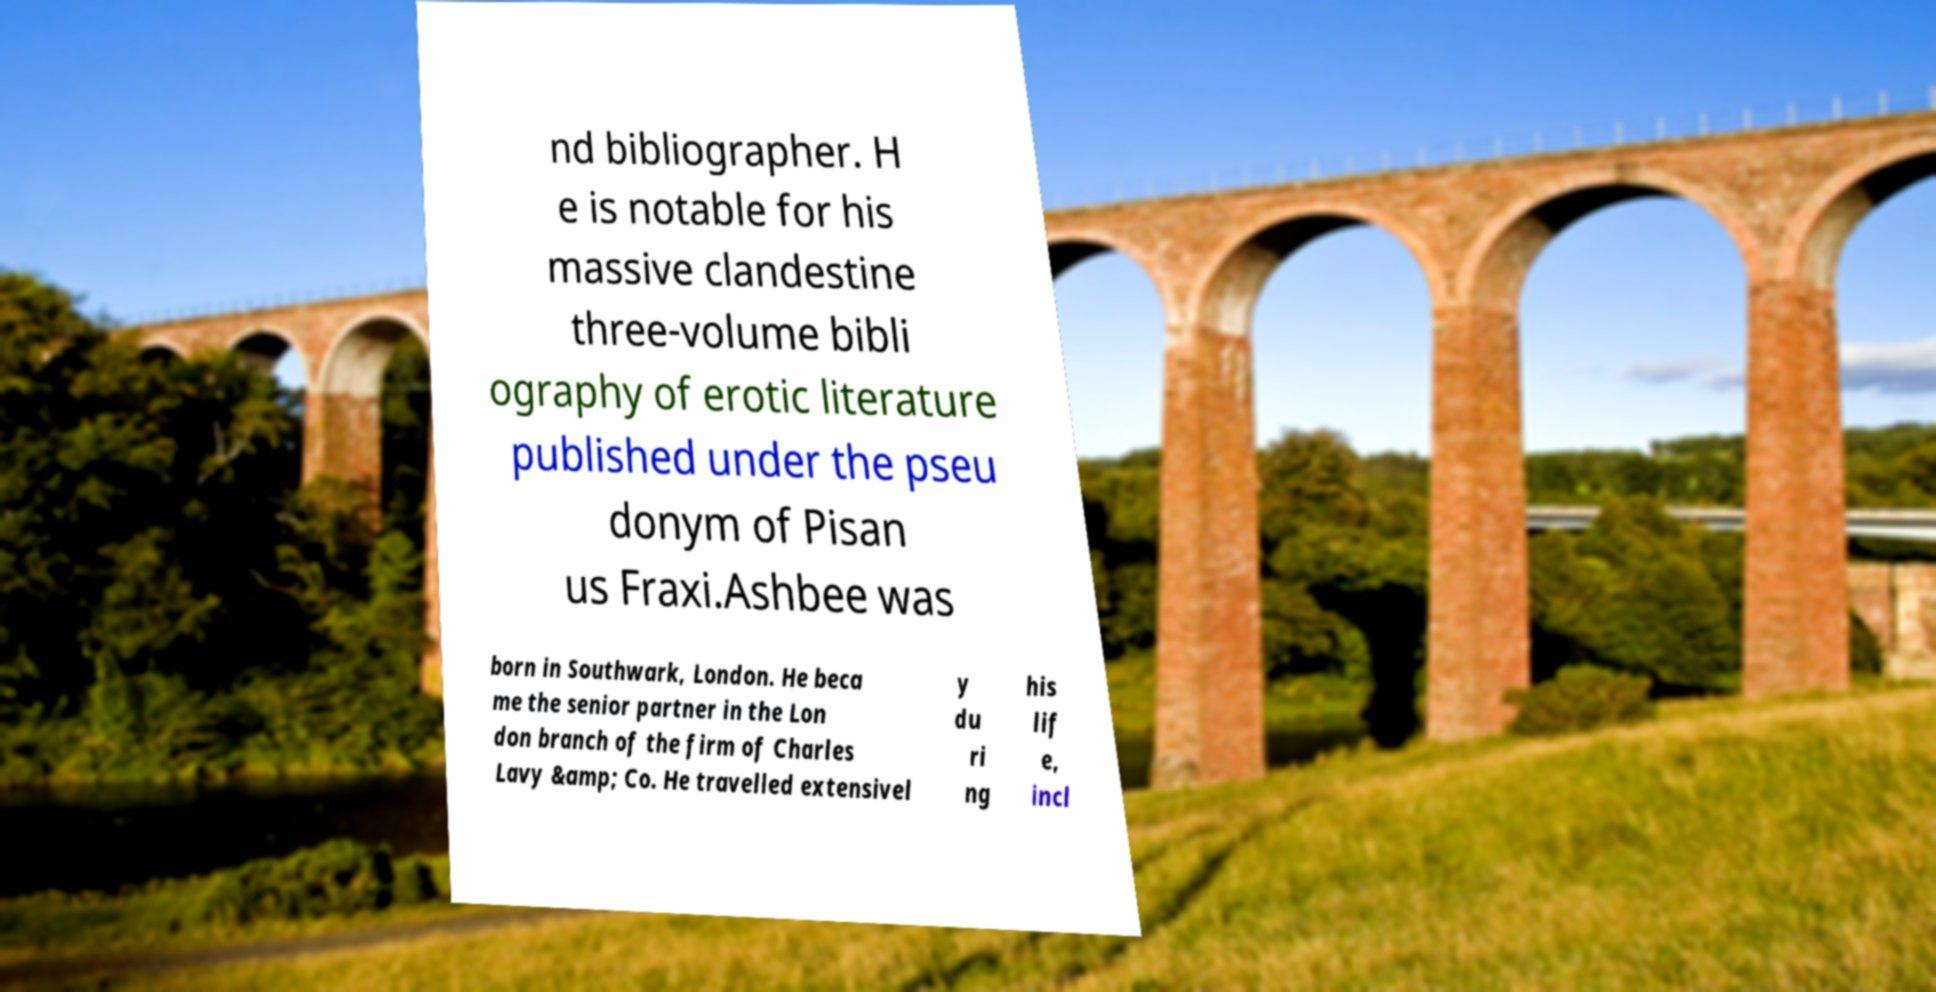Can you accurately transcribe the text from the provided image for me? nd bibliographer. H e is notable for his massive clandestine three-volume bibli ography of erotic literature published under the pseu donym of Pisan us Fraxi.Ashbee was born in Southwark, London. He beca me the senior partner in the Lon don branch of the firm of Charles Lavy &amp; Co. He travelled extensivel y du ri ng his lif e, incl 